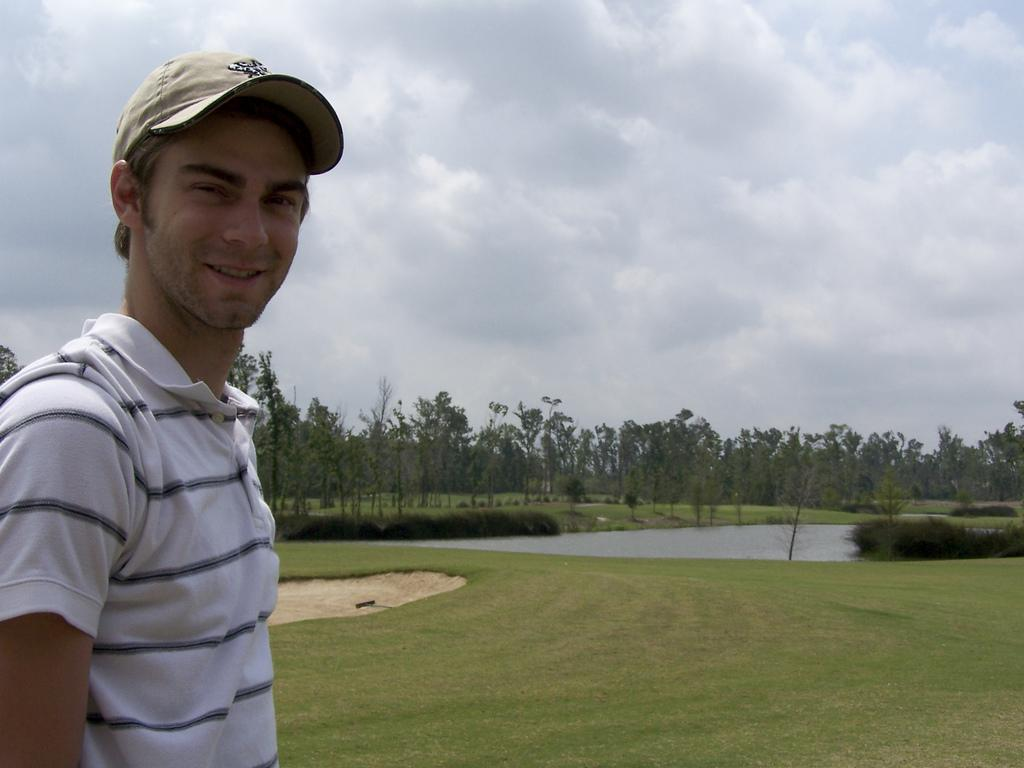What is the main subject of the image? There is a man standing in the image. What type of natural environment is visible in the image? There is grass, a water body, plants, and a group of trees visible in the image. What is the condition of the sky in the image? The sky is visible in the image and appears cloudy. What scent can be detected from the sisters in the image? There are no sisters present in the image, so no scent can be detected from them. 